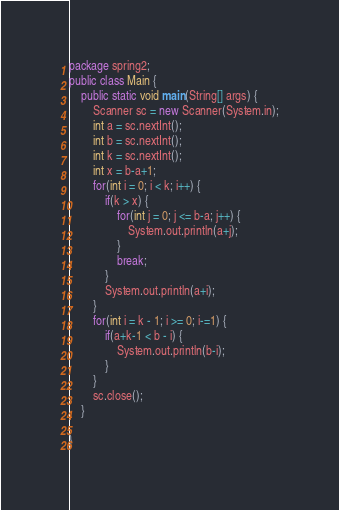Convert code to text. <code><loc_0><loc_0><loc_500><loc_500><_Java_>package spring2;
public class Main {
	public static void main(String[] args) {
		Scanner sc = new Scanner(System.in);
		int a = sc.nextInt();
		int b = sc.nextInt();
		int k = sc.nextInt();
		int x = b-a+1;
		for(int i = 0; i < k; i++) {
			if(k > x) {
				for(int j = 0; j <= b-a; j++) {
					System.out.println(a+j);
				}
				break;
			}
			System.out.println(a+i);
		}
		for(int i = k - 1; i >= 0; i-=1) {
			if(a+k-1 < b - i) {
				System.out.println(b-i);
			}
		}
		sc.close();
	}

}</code> 